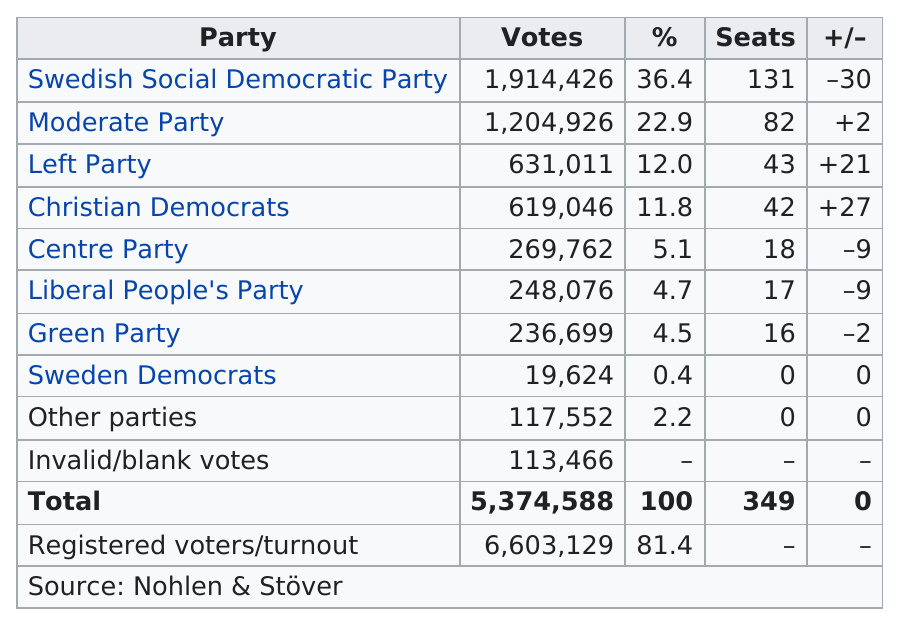Give some essential details in this illustration. The Christian Democrats achieved the best increase in the number of parliament seats. The Sweden Democrats finished last in the most recent election. The Swedish Social Democratic Party currently holds the most seats in the Swedish Parliament. 